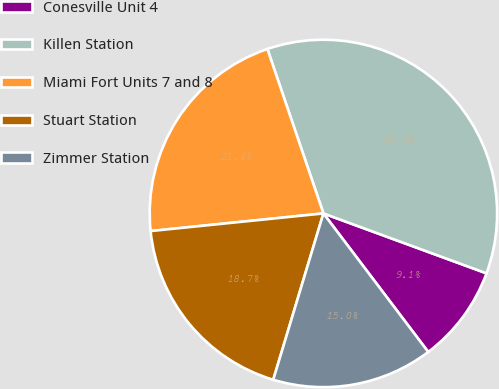Convert chart to OTSL. <chart><loc_0><loc_0><loc_500><loc_500><pie_chart><fcel>Conesville Unit 4<fcel>Killen Station<fcel>Miami Fort Units 7 and 8<fcel>Stuart Station<fcel>Zimmer Station<nl><fcel>9.09%<fcel>35.83%<fcel>21.39%<fcel>18.72%<fcel>14.97%<nl></chart> 